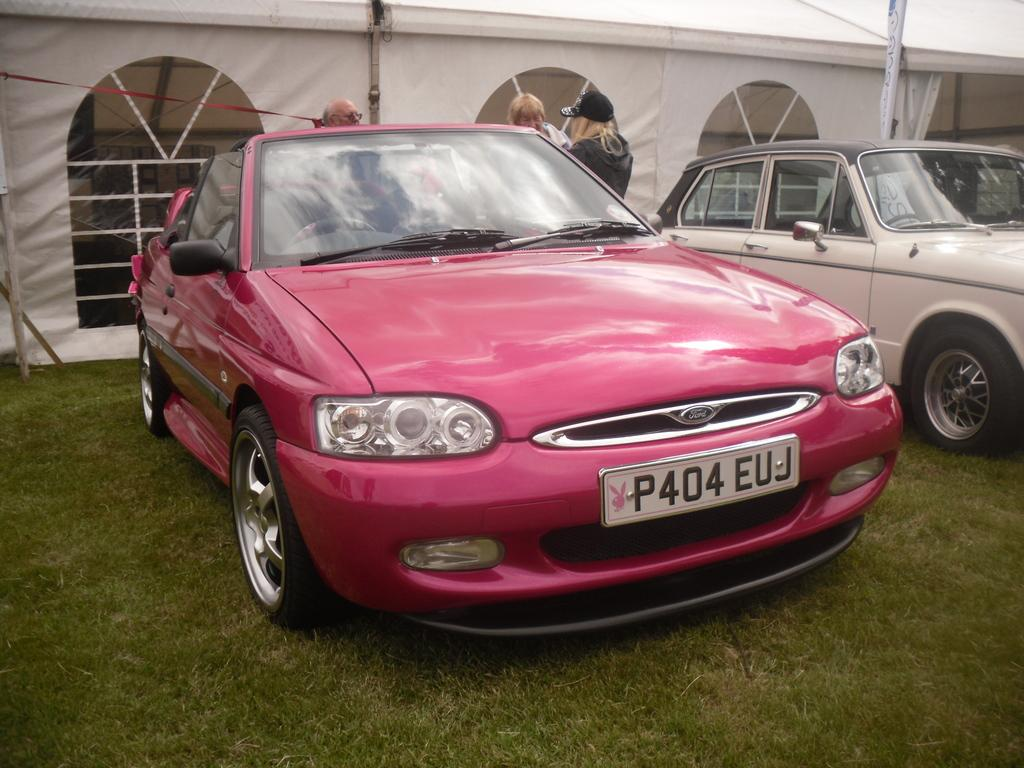<image>
Create a compact narrative representing the image presented. a pink colored Ford car is parked ont he lawn near an old white car 